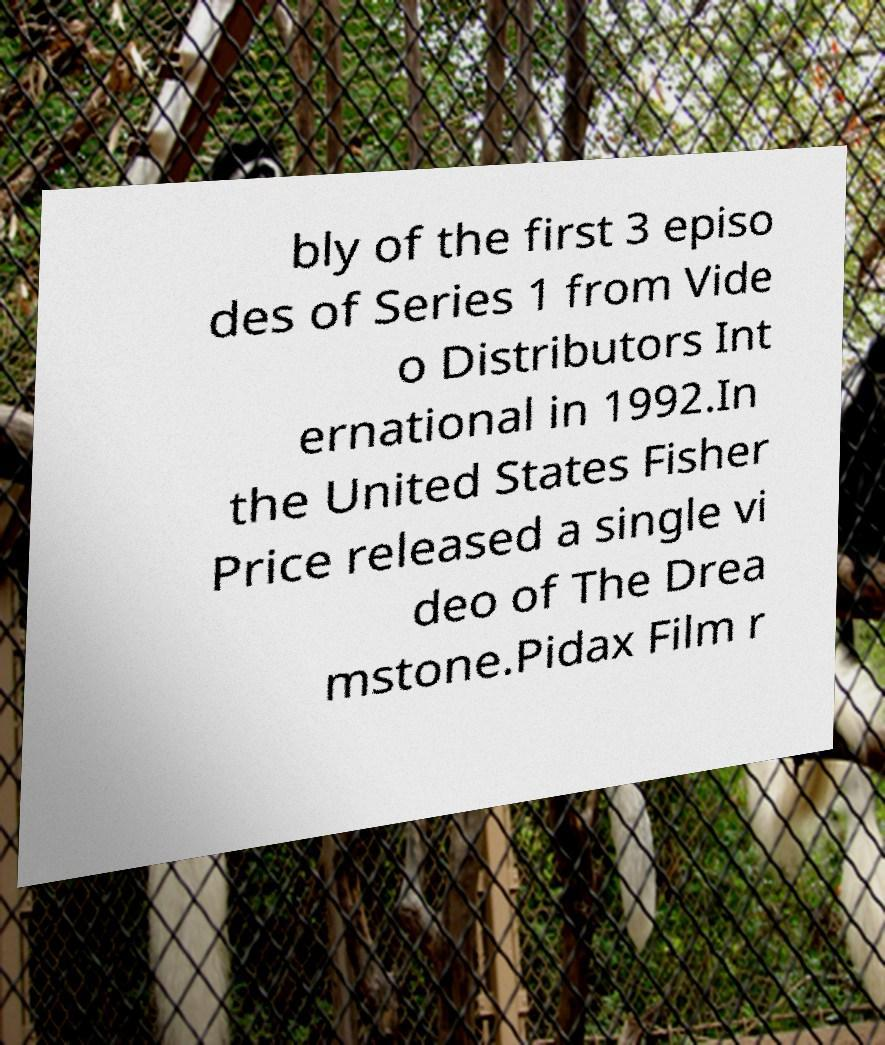Can you read and provide the text displayed in the image?This photo seems to have some interesting text. Can you extract and type it out for me? bly of the first 3 episo des of Series 1 from Vide o Distributors Int ernational in 1992.In the United States Fisher Price released a single vi deo of The Drea mstone.Pidax Film r 